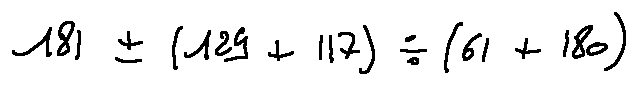<formula> <loc_0><loc_0><loc_500><loc_500>1 8 1 \pm ( 1 2 9 + 1 1 7 ) \div ( 6 1 + 1 8 0 )</formula> 